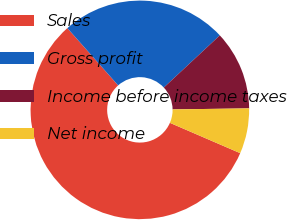Convert chart. <chart><loc_0><loc_0><loc_500><loc_500><pie_chart><fcel>Sales<fcel>Gross profit<fcel>Income before income taxes<fcel>Net income<nl><fcel>56.96%<fcel>24.61%<fcel>11.72%<fcel>6.7%<nl></chart> 